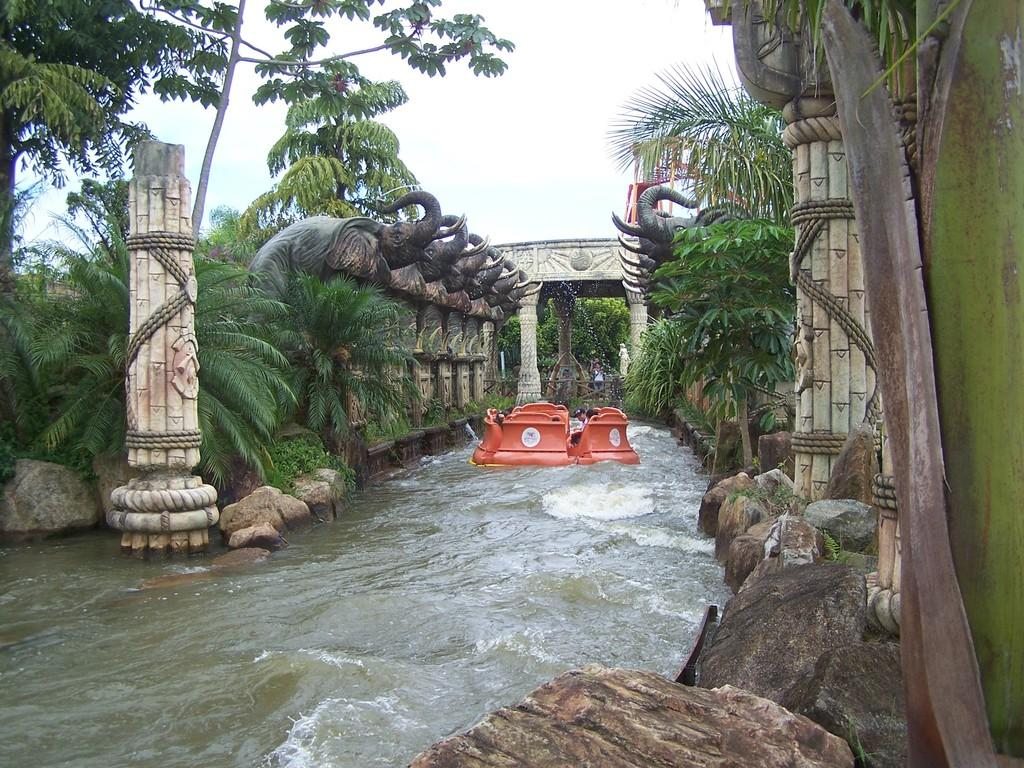What color is the object that is on the water in the image? The object on the water is red. What type of animals are depicted as statues in the image? The statues in the image are of elephants. What type of vegetation is present in the image? Trees and plants are visible in the image. What architectural features can be seen in the image? Pillars are present in the image. What type of natural features are visible in the image? Rocks are present in the image. What is visible in the background of the image? The sky is visible in the background of the image. How many bears are sitting on the red object in the image? There are no bears present in the image. What type of room is depicted in the image? The image does not show a room; it features a red object on the water, statues of elephants, trees, plants, pillars, rocks, and the sky in the background. 